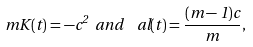Convert formula to latex. <formula><loc_0><loc_0><loc_500><loc_500>\ m K ( t ) = - c ^ { 2 } \ a n d \ \ a l ( t ) = \frac { ( m - 1 ) c } { m } ,</formula> 